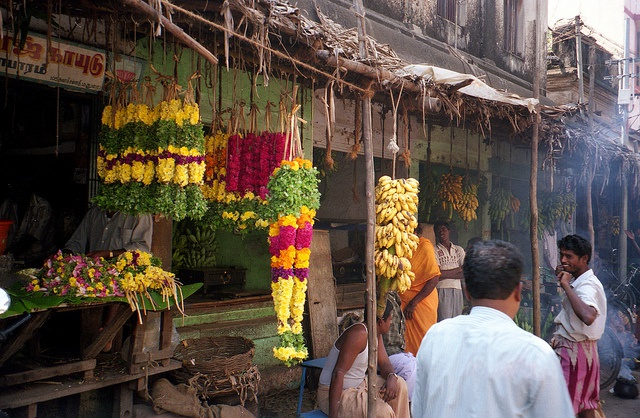Describe the objects in this image and their specific colors. I can see people in black, lavender, lightgray, and darkgray tones, people in black, brown, maroon, and gray tones, people in black, maroon, brown, and gray tones, people in black, maroon, and gray tones, and people in black and gray tones in this image. 